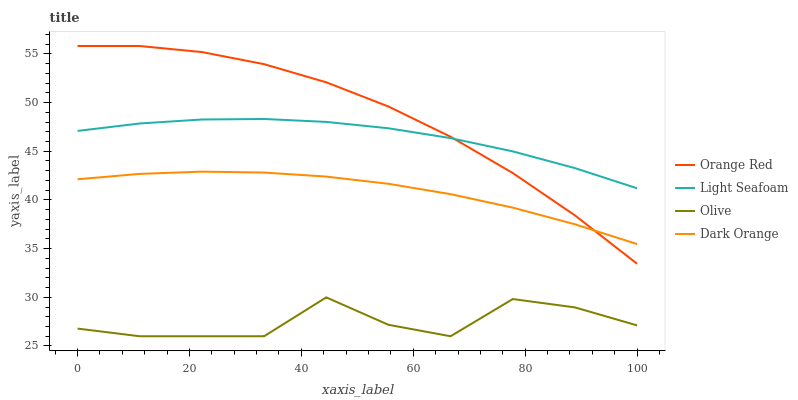Does Olive have the minimum area under the curve?
Answer yes or no. Yes. Does Orange Red have the maximum area under the curve?
Answer yes or no. Yes. Does Dark Orange have the minimum area under the curve?
Answer yes or no. No. Does Dark Orange have the maximum area under the curve?
Answer yes or no. No. Is Dark Orange the smoothest?
Answer yes or no. Yes. Is Olive the roughest?
Answer yes or no. Yes. Is Light Seafoam the smoothest?
Answer yes or no. No. Is Light Seafoam the roughest?
Answer yes or no. No. Does Olive have the lowest value?
Answer yes or no. Yes. Does Dark Orange have the lowest value?
Answer yes or no. No. Does Orange Red have the highest value?
Answer yes or no. Yes. Does Dark Orange have the highest value?
Answer yes or no. No. Is Olive less than Light Seafoam?
Answer yes or no. Yes. Is Light Seafoam greater than Olive?
Answer yes or no. Yes. Does Dark Orange intersect Orange Red?
Answer yes or no. Yes. Is Dark Orange less than Orange Red?
Answer yes or no. No. Is Dark Orange greater than Orange Red?
Answer yes or no. No. Does Olive intersect Light Seafoam?
Answer yes or no. No. 